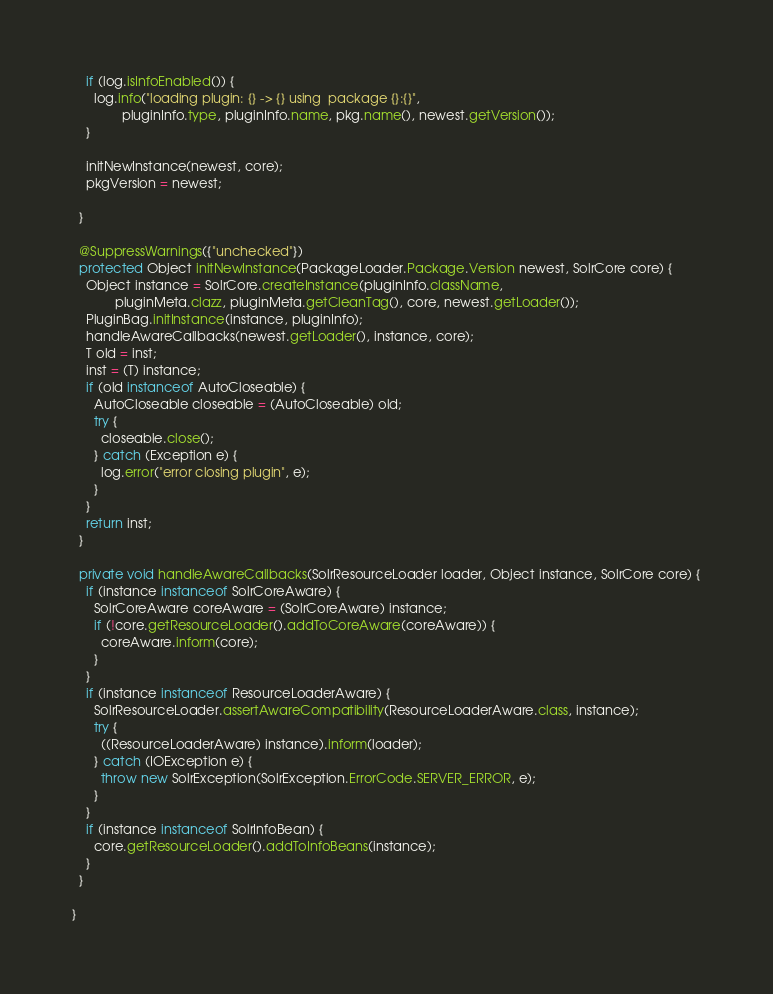<code> <loc_0><loc_0><loc_500><loc_500><_Java_>    if (log.isInfoEnabled()) {
      log.info("loading plugin: {} -> {} using  package {}:{}",
              pluginInfo.type, pluginInfo.name, pkg.name(), newest.getVersion());
    }

    initNewInstance(newest, core);
    pkgVersion = newest;

  }

  @SuppressWarnings({"unchecked"})
  protected Object initNewInstance(PackageLoader.Package.Version newest, SolrCore core) {
    Object instance = SolrCore.createInstance(pluginInfo.className,
            pluginMeta.clazz, pluginMeta.getCleanTag(), core, newest.getLoader());
    PluginBag.initInstance(instance, pluginInfo);
    handleAwareCallbacks(newest.getLoader(), instance, core);
    T old = inst;
    inst = (T) instance;
    if (old instanceof AutoCloseable) {
      AutoCloseable closeable = (AutoCloseable) old;
      try {
        closeable.close();
      } catch (Exception e) {
        log.error("error closing plugin", e);
      }
    }
    return inst;
  }

  private void handleAwareCallbacks(SolrResourceLoader loader, Object instance, SolrCore core) {
    if (instance instanceof SolrCoreAware) {
      SolrCoreAware coreAware = (SolrCoreAware) instance;
      if (!core.getResourceLoader().addToCoreAware(coreAware)) {
        coreAware.inform(core);
      }
    }
    if (instance instanceof ResourceLoaderAware) {
      SolrResourceLoader.assertAwareCompatibility(ResourceLoaderAware.class, instance);
      try {
        ((ResourceLoaderAware) instance).inform(loader);
      } catch (IOException e) {
        throw new SolrException(SolrException.ErrorCode.SERVER_ERROR, e);
      }
    }
    if (instance instanceof SolrInfoBean) {
      core.getResourceLoader().addToInfoBeans(instance);
    }
  }

}</code> 